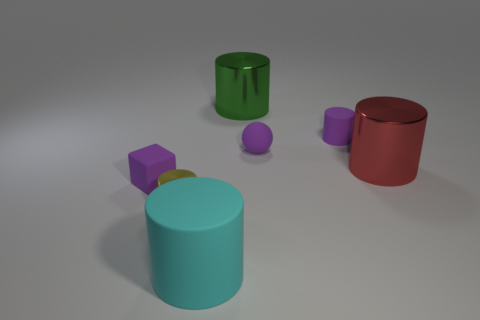Subtract all cyan cylinders. How many cylinders are left? 4 Subtract all cyan cylinders. How many cylinders are left? 4 Subtract 1 cylinders. How many cylinders are left? 4 Subtract all blue cylinders. Subtract all purple cubes. How many cylinders are left? 5 Add 1 tiny green rubber cylinders. How many objects exist? 8 Subtract all cylinders. How many objects are left? 2 Subtract 1 cyan cylinders. How many objects are left? 6 Subtract all tiny purple balls. Subtract all small cylinders. How many objects are left? 4 Add 5 big metal cylinders. How many big metal cylinders are left? 7 Add 6 big cyan blocks. How many big cyan blocks exist? 6 